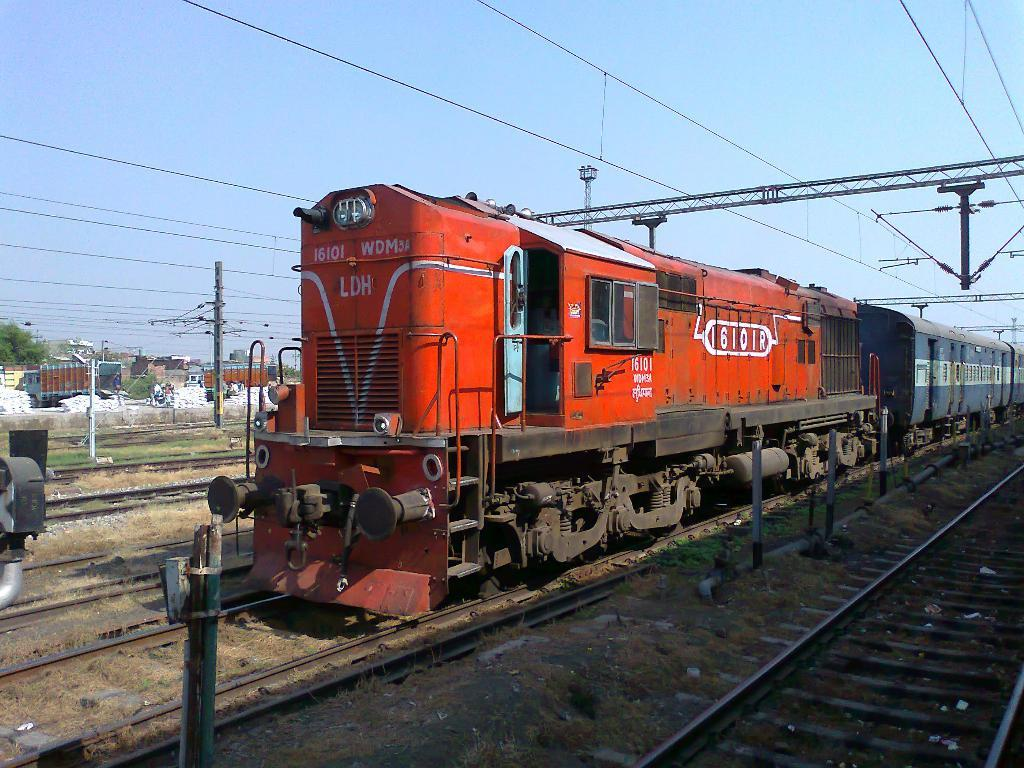Provide a one-sentence caption for the provided image. A red train with 16101 WDMY written across the front of it. 